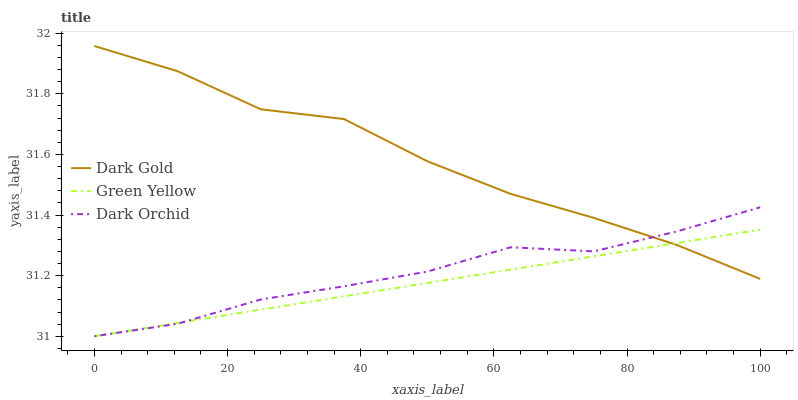Does Green Yellow have the minimum area under the curve?
Answer yes or no. Yes. Does Dark Gold have the maximum area under the curve?
Answer yes or no. Yes. Does Dark Orchid have the minimum area under the curve?
Answer yes or no. No. Does Dark Orchid have the maximum area under the curve?
Answer yes or no. No. Is Green Yellow the smoothest?
Answer yes or no. Yes. Is Dark Gold the roughest?
Answer yes or no. Yes. Is Dark Orchid the smoothest?
Answer yes or no. No. Is Dark Orchid the roughest?
Answer yes or no. No. Does Dark Gold have the lowest value?
Answer yes or no. No. Does Dark Gold have the highest value?
Answer yes or no. Yes. Does Dark Orchid have the highest value?
Answer yes or no. No. Does Dark Gold intersect Green Yellow?
Answer yes or no. Yes. Is Dark Gold less than Green Yellow?
Answer yes or no. No. Is Dark Gold greater than Green Yellow?
Answer yes or no. No. 